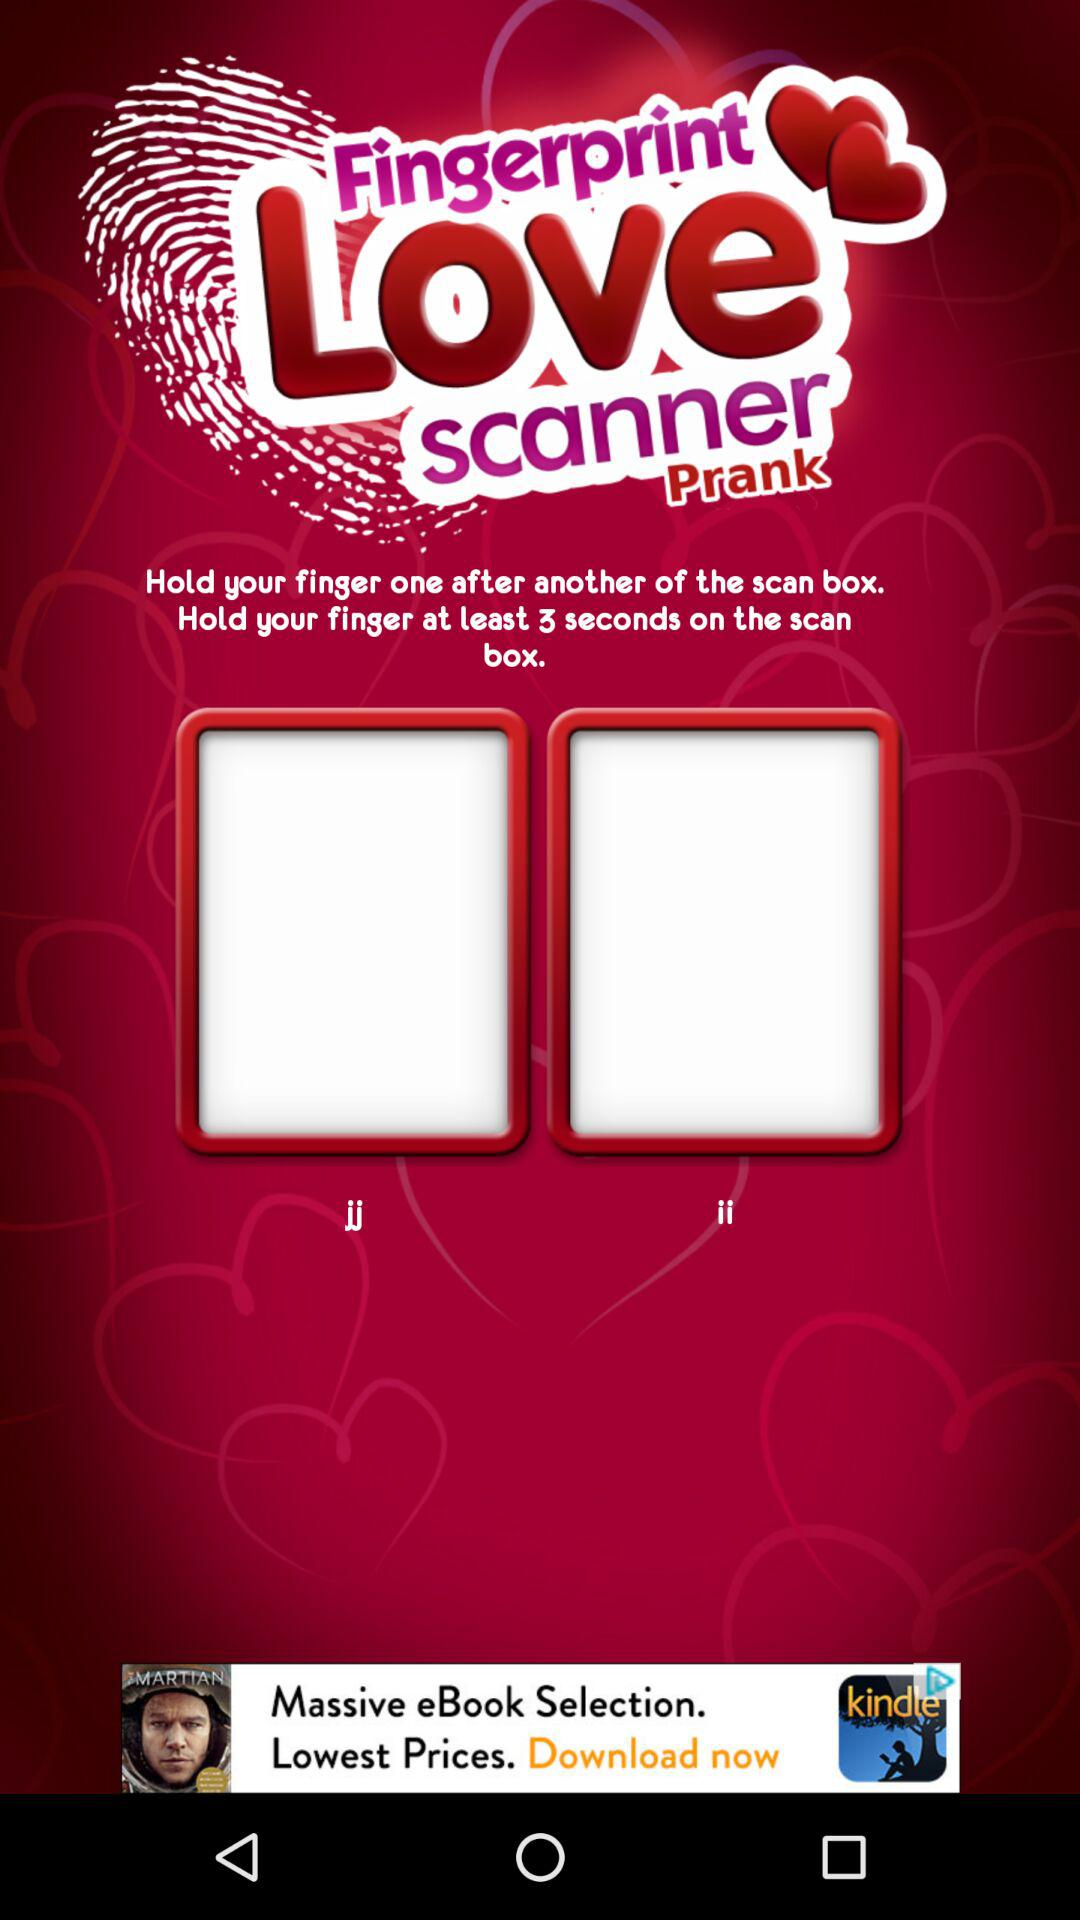How many red frames are there?
Answer the question using a single word or phrase. 2 